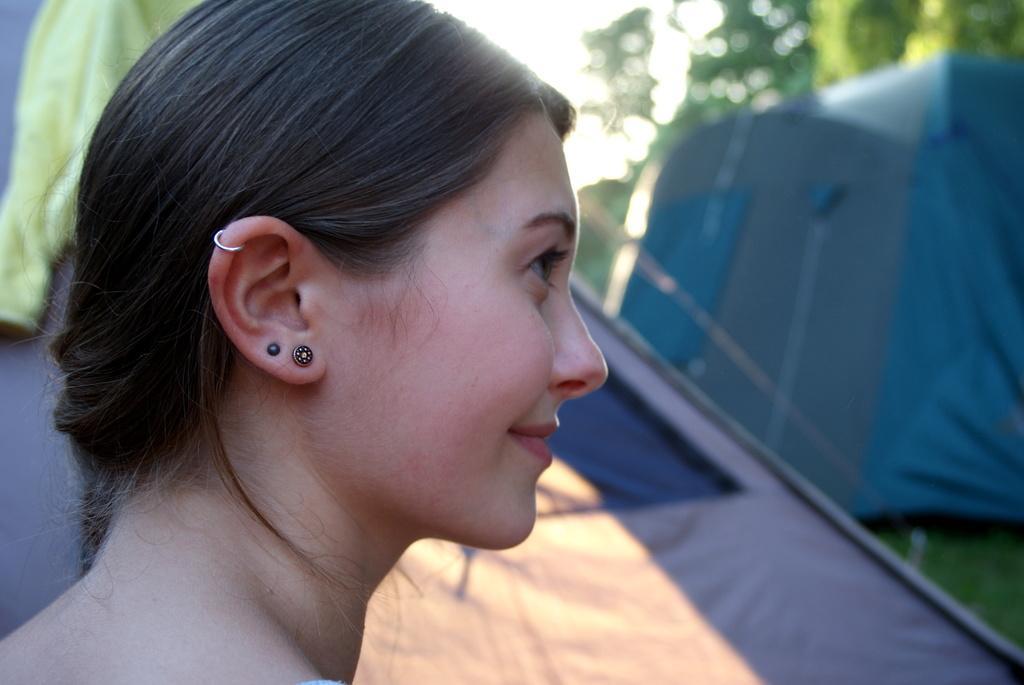In one or two sentences, can you explain what this image depicts? In this picture we can see a woman is smiling in the front, there are tents and grass in the background, we can see a blurry background. 